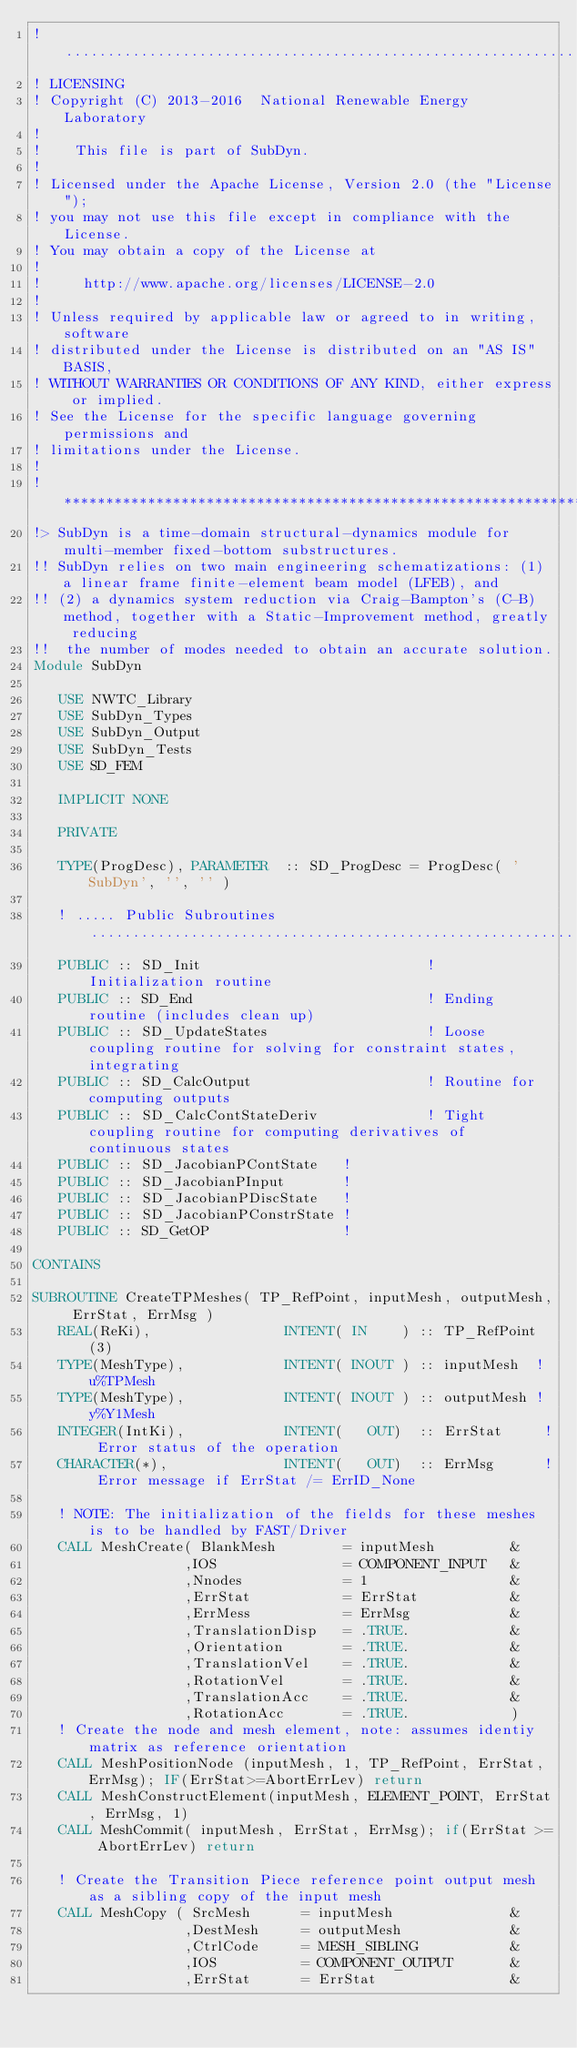<code> <loc_0><loc_0><loc_500><loc_500><_FORTRAN_>!..................................................................................................................................
! LICENSING
! Copyright (C) 2013-2016  National Renewable Energy Laboratory
!
!    This file is part of SubDyn.   
!
! Licensed under the Apache License, Version 2.0 (the "License");
! you may not use this file except in compliance with the License.
! You may obtain a copy of the License at
!
!     http://www.apache.org/licenses/LICENSE-2.0
!
! Unless required by applicable law or agreed to in writing, software
! distributed under the License is distributed on an "AS IS" BASIS,
! WITHOUT WARRANTIES OR CONDITIONS OF ANY KIND, either express or implied.
! See the License for the specific language governing permissions and
! limitations under the License.
!
!**********************************************************************************************************************************
!> SubDyn is a time-domain structural-dynamics module for multi-member fixed-bottom substructures.
!! SubDyn relies on two main engineering schematizations: (1) a linear frame finite-element beam model (LFEB), and 
!! (2) a dynamics system reduction via Craig-Bampton's (C-B) method, together with a Static-Improvement method, greatly reducing 
!!  the number of modes needed to obtain an accurate solution.   
Module SubDyn
   
   USE NWTC_Library
   USE SubDyn_Types
   USE SubDyn_Output
   USE SubDyn_Tests
   USE SD_FEM
   
   IMPLICIT NONE

   PRIVATE
   
   TYPE(ProgDesc), PARAMETER  :: SD_ProgDesc = ProgDesc( 'SubDyn', '', '' )
      
   ! ..... Public Subroutines ...................................................................................................
   PUBLIC :: SD_Init                           ! Initialization routine
   PUBLIC :: SD_End                            ! Ending routine (includes clean up)
   PUBLIC :: SD_UpdateStates                   ! Loose coupling routine for solving for constraint states, integrating
   PUBLIC :: SD_CalcOutput                     ! Routine for computing outputs
   PUBLIC :: SD_CalcContStateDeriv             ! Tight coupling routine for computing derivatives of continuous states
   PUBLIC :: SD_JacobianPContState   ! 
   PUBLIC :: SD_JacobianPInput       ! 
   PUBLIC :: SD_JacobianPDiscState   ! 
   PUBLIC :: SD_JacobianPConstrState ! 
   PUBLIC :: SD_GetOP                ! 
   
CONTAINS

SUBROUTINE CreateTPMeshes( TP_RefPoint, inputMesh, outputMesh, ErrStat, ErrMsg )
   REAL(ReKi),                INTENT( IN    ) :: TP_RefPoint(3)
   TYPE(MeshType),            INTENT( INOUT ) :: inputMesh  ! u%TPMesh
   TYPE(MeshType),            INTENT( INOUT ) :: outputMesh ! y%Y1Mesh
   INTEGER(IntKi),            INTENT(   OUT)  :: ErrStat     ! Error status of the operation
   CHARACTER(*),              INTENT(   OUT)  :: ErrMsg      ! Error message if ErrStat /= ErrID_None
   
   ! NOTE: The initialization of the fields for these meshes is to be handled by FAST/Driver
   CALL MeshCreate( BlankMesh        = inputMesh         &
                  ,IOS               = COMPONENT_INPUT   &
                  ,Nnodes            = 1                 &
                  ,ErrStat           = ErrStat           &
                  ,ErrMess           = ErrMsg            &
                  ,TranslationDisp   = .TRUE.            &
                  ,Orientation       = .TRUE.            &
                  ,TranslationVel    = .TRUE.            &
                  ,RotationVel       = .TRUE.            &
                  ,TranslationAcc    = .TRUE.            &
                  ,RotationAcc       = .TRUE.            )
   ! Create the node and mesh element, note: assumes identiy matrix as reference orientation
   CALL MeshPositionNode (inputMesh, 1, TP_RefPoint, ErrStat, ErrMsg); IF(ErrStat>=AbortErrLev) return
   CALL MeshConstructElement(inputMesh, ELEMENT_POINT, ErrStat, ErrMsg, 1)
   CALL MeshCommit( inputMesh, ErrStat, ErrMsg); if(ErrStat >= AbortErrLev) return
   
   ! Create the Transition Piece reference point output mesh as a sibling copy of the input mesh
   CALL MeshCopy ( SrcMesh      = inputMesh              &
                  ,DestMesh     = outputMesh             &
                  ,CtrlCode     = MESH_SIBLING           &
                  ,IOS          = COMPONENT_OUTPUT       &
                  ,ErrStat      = ErrStat                &</code> 